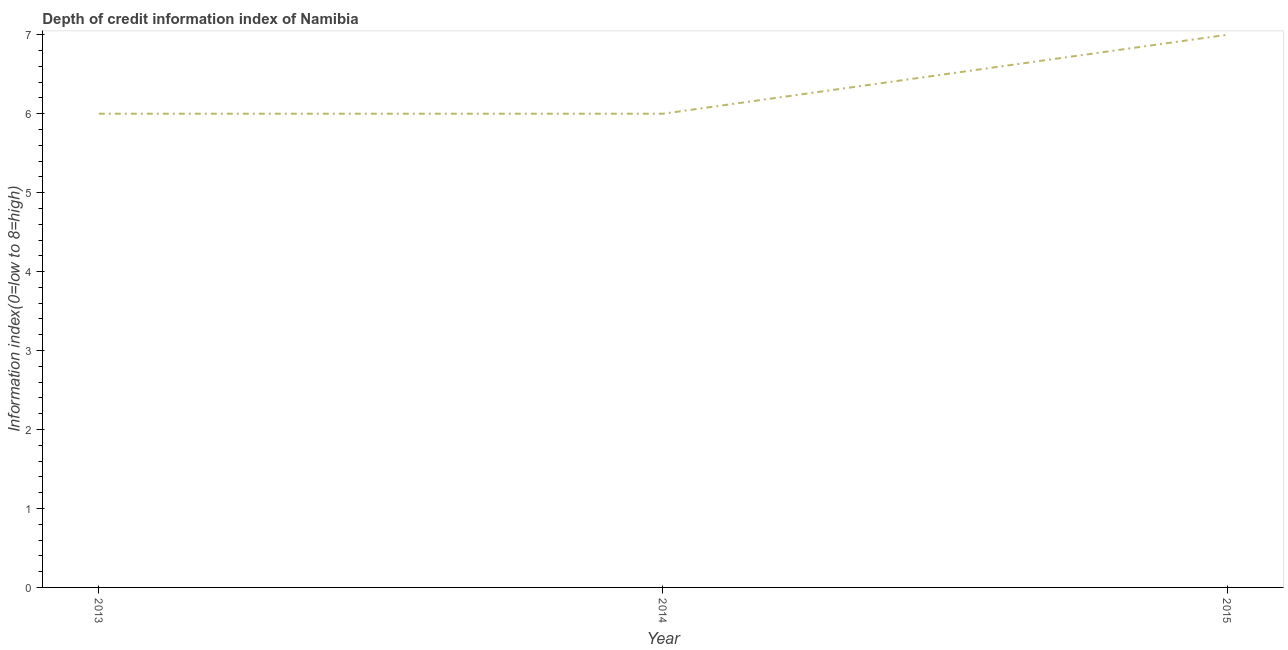Across all years, what is the maximum depth of credit information index?
Your answer should be very brief. 7. In which year was the depth of credit information index maximum?
Provide a short and direct response. 2015. In which year was the depth of credit information index minimum?
Your answer should be compact. 2013. What is the sum of the depth of credit information index?
Your answer should be compact. 19. What is the average depth of credit information index per year?
Ensure brevity in your answer.  6.33. What is the median depth of credit information index?
Your answer should be very brief. 6. What is the difference between the highest and the second highest depth of credit information index?
Give a very brief answer. 1. What is the difference between the highest and the lowest depth of credit information index?
Give a very brief answer. 1. How many lines are there?
Your answer should be very brief. 1. What is the difference between two consecutive major ticks on the Y-axis?
Your answer should be compact. 1. Does the graph contain any zero values?
Your answer should be very brief. No. Does the graph contain grids?
Provide a succinct answer. No. What is the title of the graph?
Your answer should be very brief. Depth of credit information index of Namibia. What is the label or title of the Y-axis?
Your answer should be compact. Information index(0=low to 8=high). What is the Information index(0=low to 8=high) in 2014?
Offer a terse response. 6. What is the difference between the Information index(0=low to 8=high) in 2014 and 2015?
Give a very brief answer. -1. What is the ratio of the Information index(0=low to 8=high) in 2013 to that in 2014?
Give a very brief answer. 1. What is the ratio of the Information index(0=low to 8=high) in 2013 to that in 2015?
Keep it short and to the point. 0.86. What is the ratio of the Information index(0=low to 8=high) in 2014 to that in 2015?
Offer a terse response. 0.86. 